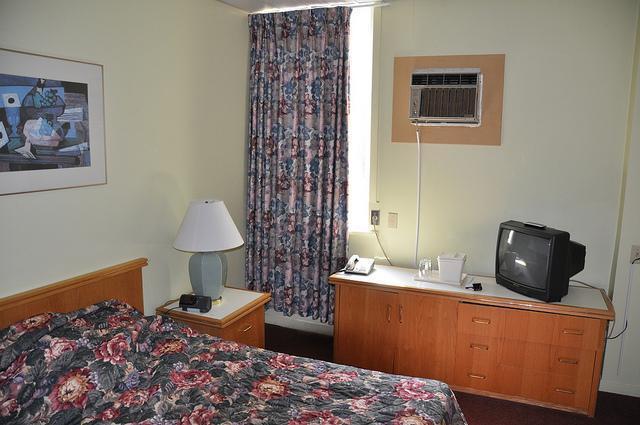What is on the dresser?
Answer the question by selecting the correct answer among the 4 following choices.
Options: Roses, books, television, apple pie. Television. 